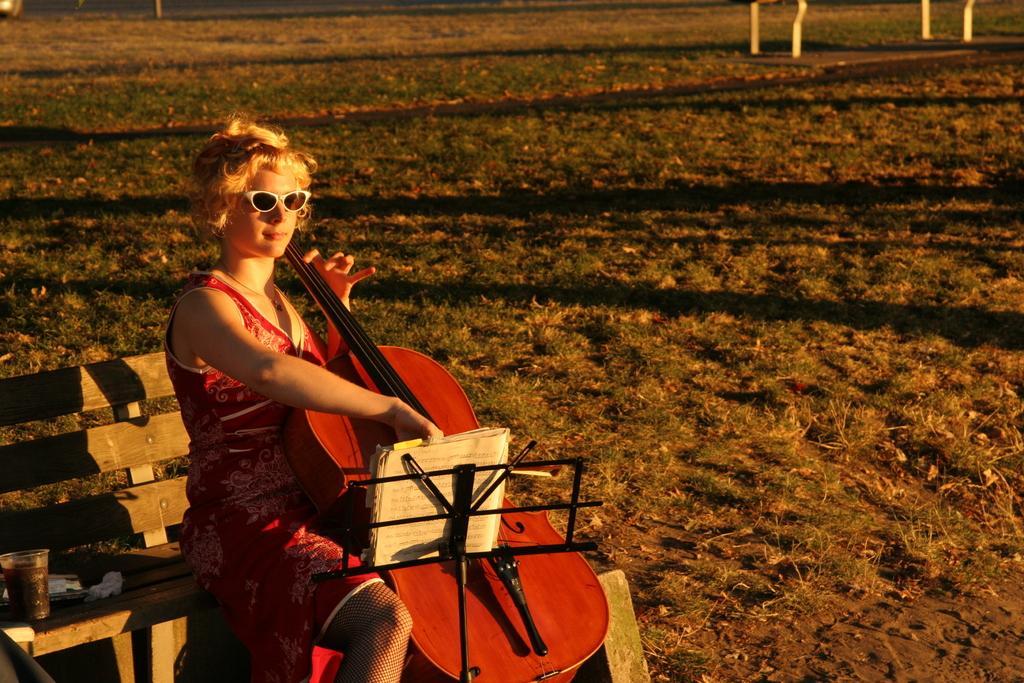Can you describe this image briefly? A woman is sitting on the bench and playing the guitar by looking into the book. This is a grass. 